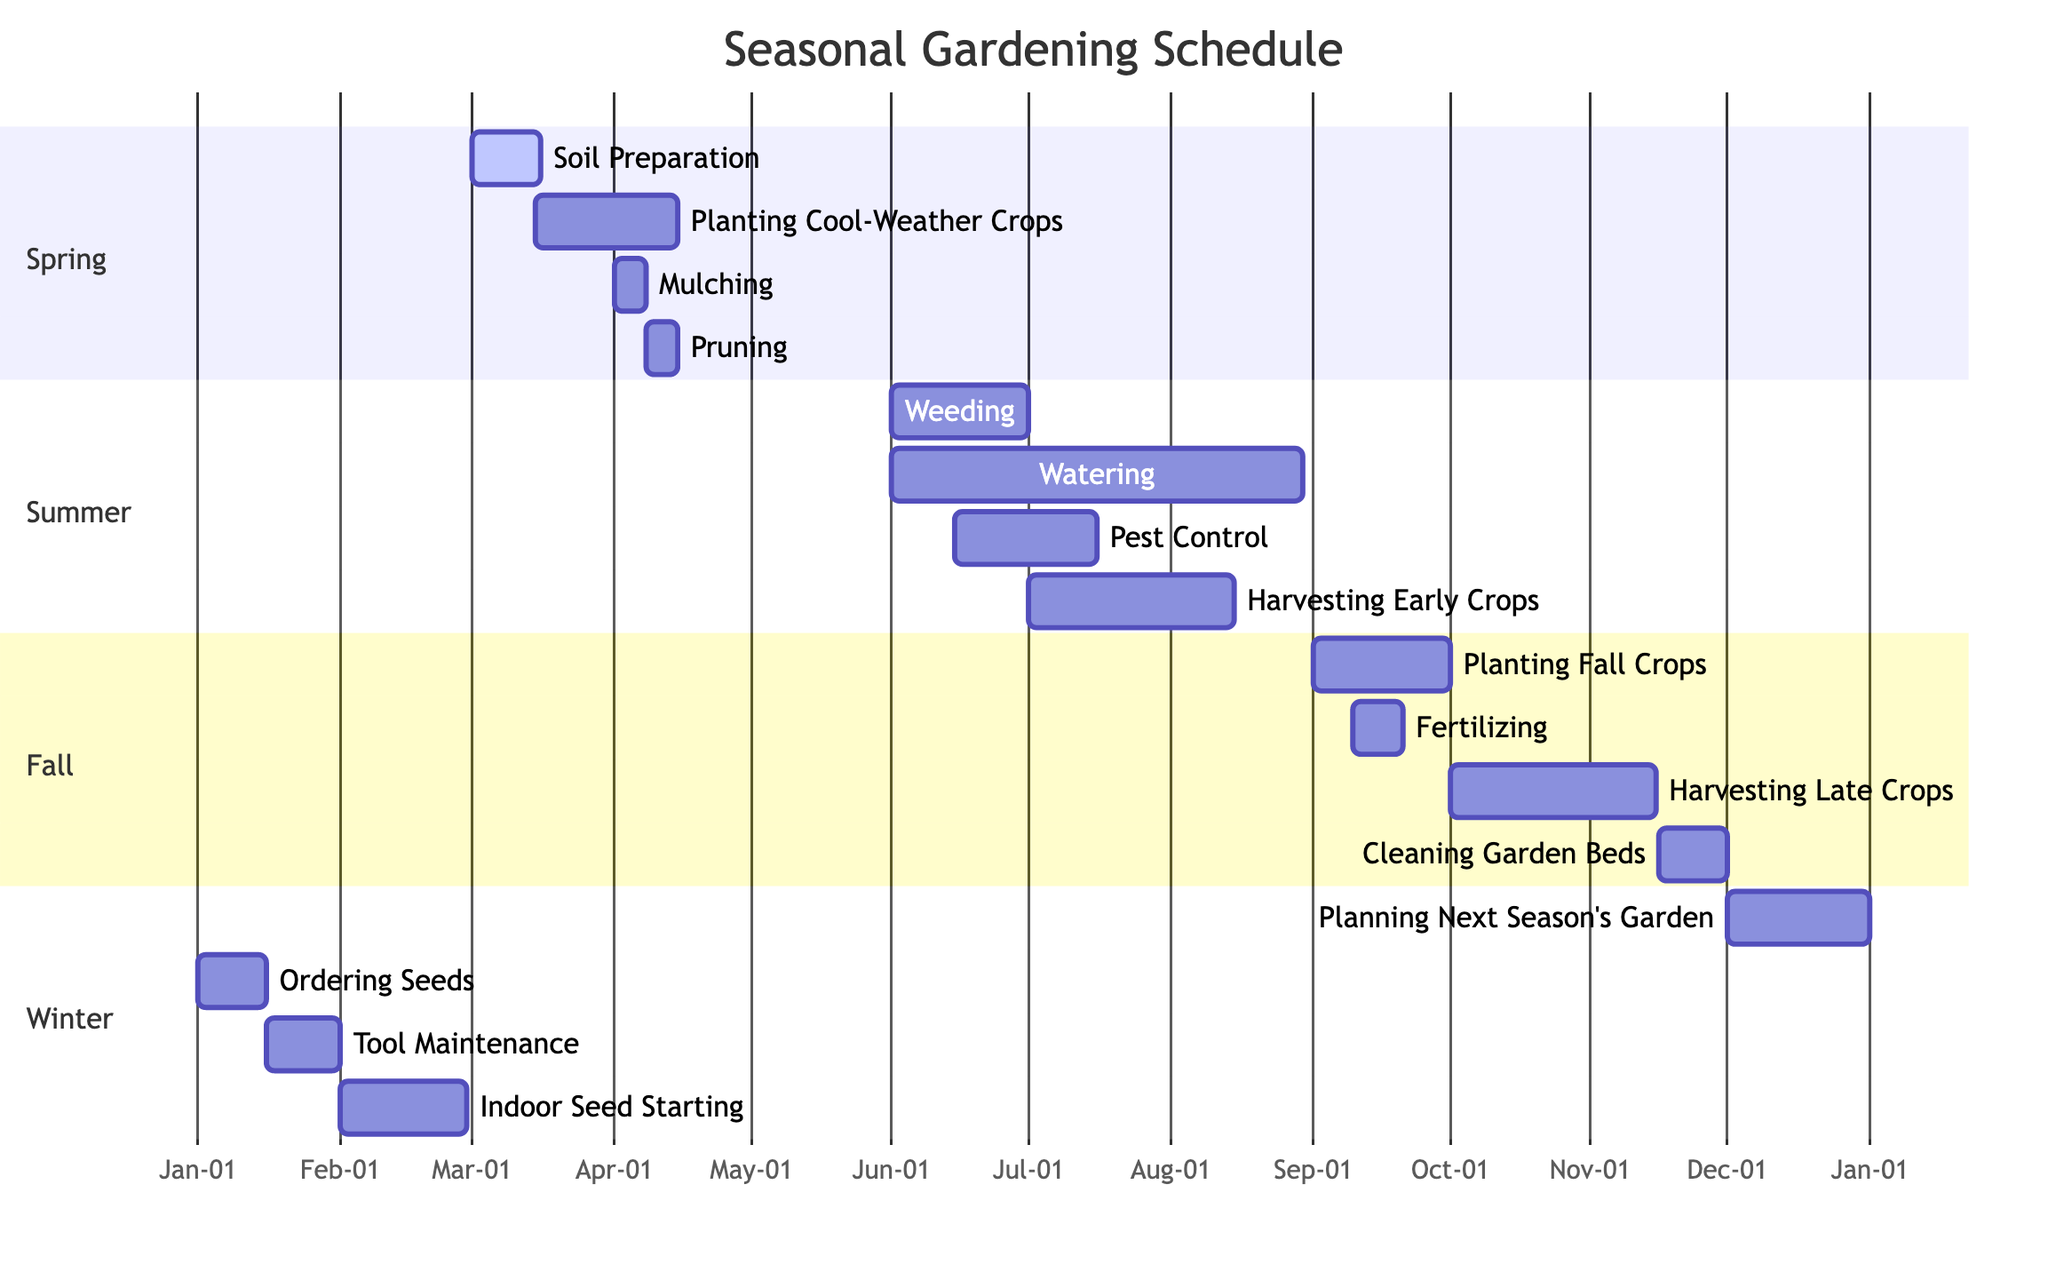What is the duration of "Soil Preparation"? The "Soil Preparation" activity starts on March 1 and ends on March 15. The duration can be calculated by counting the days from the start date to the end date, which totals 15 days.
Answer: 15 days Which activity occurs last in the Summer section? To find the last activity in the Summer section, we look at the end dates of all activities. The last activity is "Harvesting Early Crops," which ends on August 15.
Answer: Harvesting Early Crops How many activities are there in the Fall section? By counting the listed activities under the Fall section, there are four activities: "Planting Fall Crops," "Fertilizing," "Harvesting Late Crops," and "Cleaning Garden Beds."
Answer: 4 What activity overlaps with "Planting Fall Crops"? The "Planting Fall Crops" activity starts on September 1 and ends on September 30. "Fertilizing" starts on September 10 and ends on September 20, which overlaps with "Planting Fall Crops."
Answer: Fertilizing In which season is "Indoor Seed Starting" scheduled? The "Indoor Seed Starting" activity is listed under the Winter season, starting on February 1 and ending on February 28.
Answer: Winter What is the first activity of the Spring section? The first activity listed in the Spring section is "Soil Preparation," which starts on March 1.
Answer: Soil Preparation Which activity has the longest duration in the entire schedule? By reviewing all activities and their durations, "Watering" lasts from June 1 to August 30, totaling 90 days, longer than any other activity.
Answer: Watering How many days does "Tool Maintenance" take? The "Tool Maintenance" activity starts on January 16 and ends on January 31. The duration from the start to the end date is 16 days.
Answer: 16 days Which season involves "Weeding"? The "Weeding" activity is located in the Summer section of the diagram, starting on June 1 and ending on June 30.
Answer: Summer 